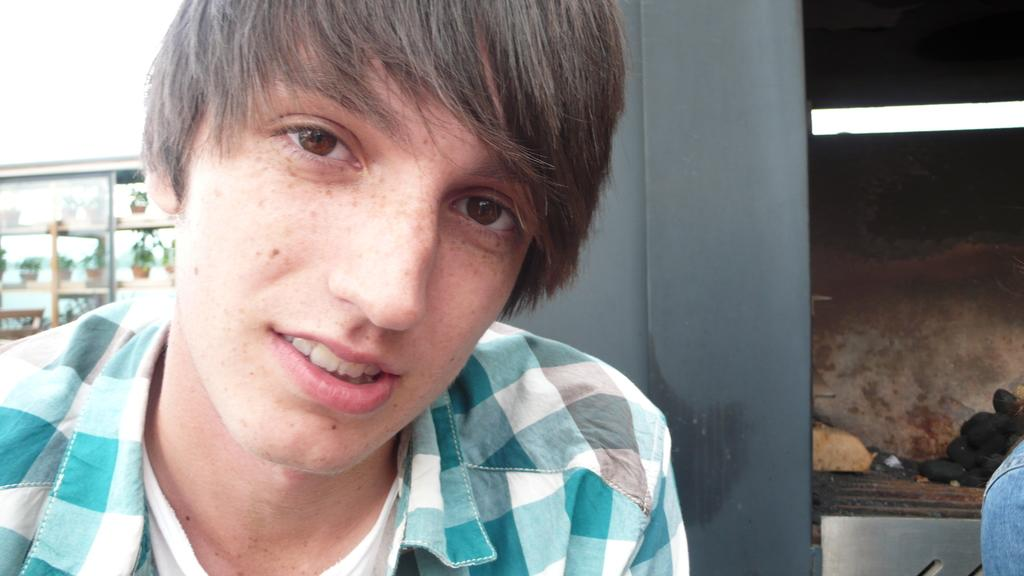Who is the main subject in the image? There is a boy in the image. What is the boy doing in the image? The boy is talking. What is the boy wearing in the image? The boy is wearing a shirt. What can be seen on the left side of the image? There are plants on shelves with a glass wall on the left side of the image. What type of poison can be seen on the boy's shirt in the image? There is no poison present on the boy's shirt or in the image. 